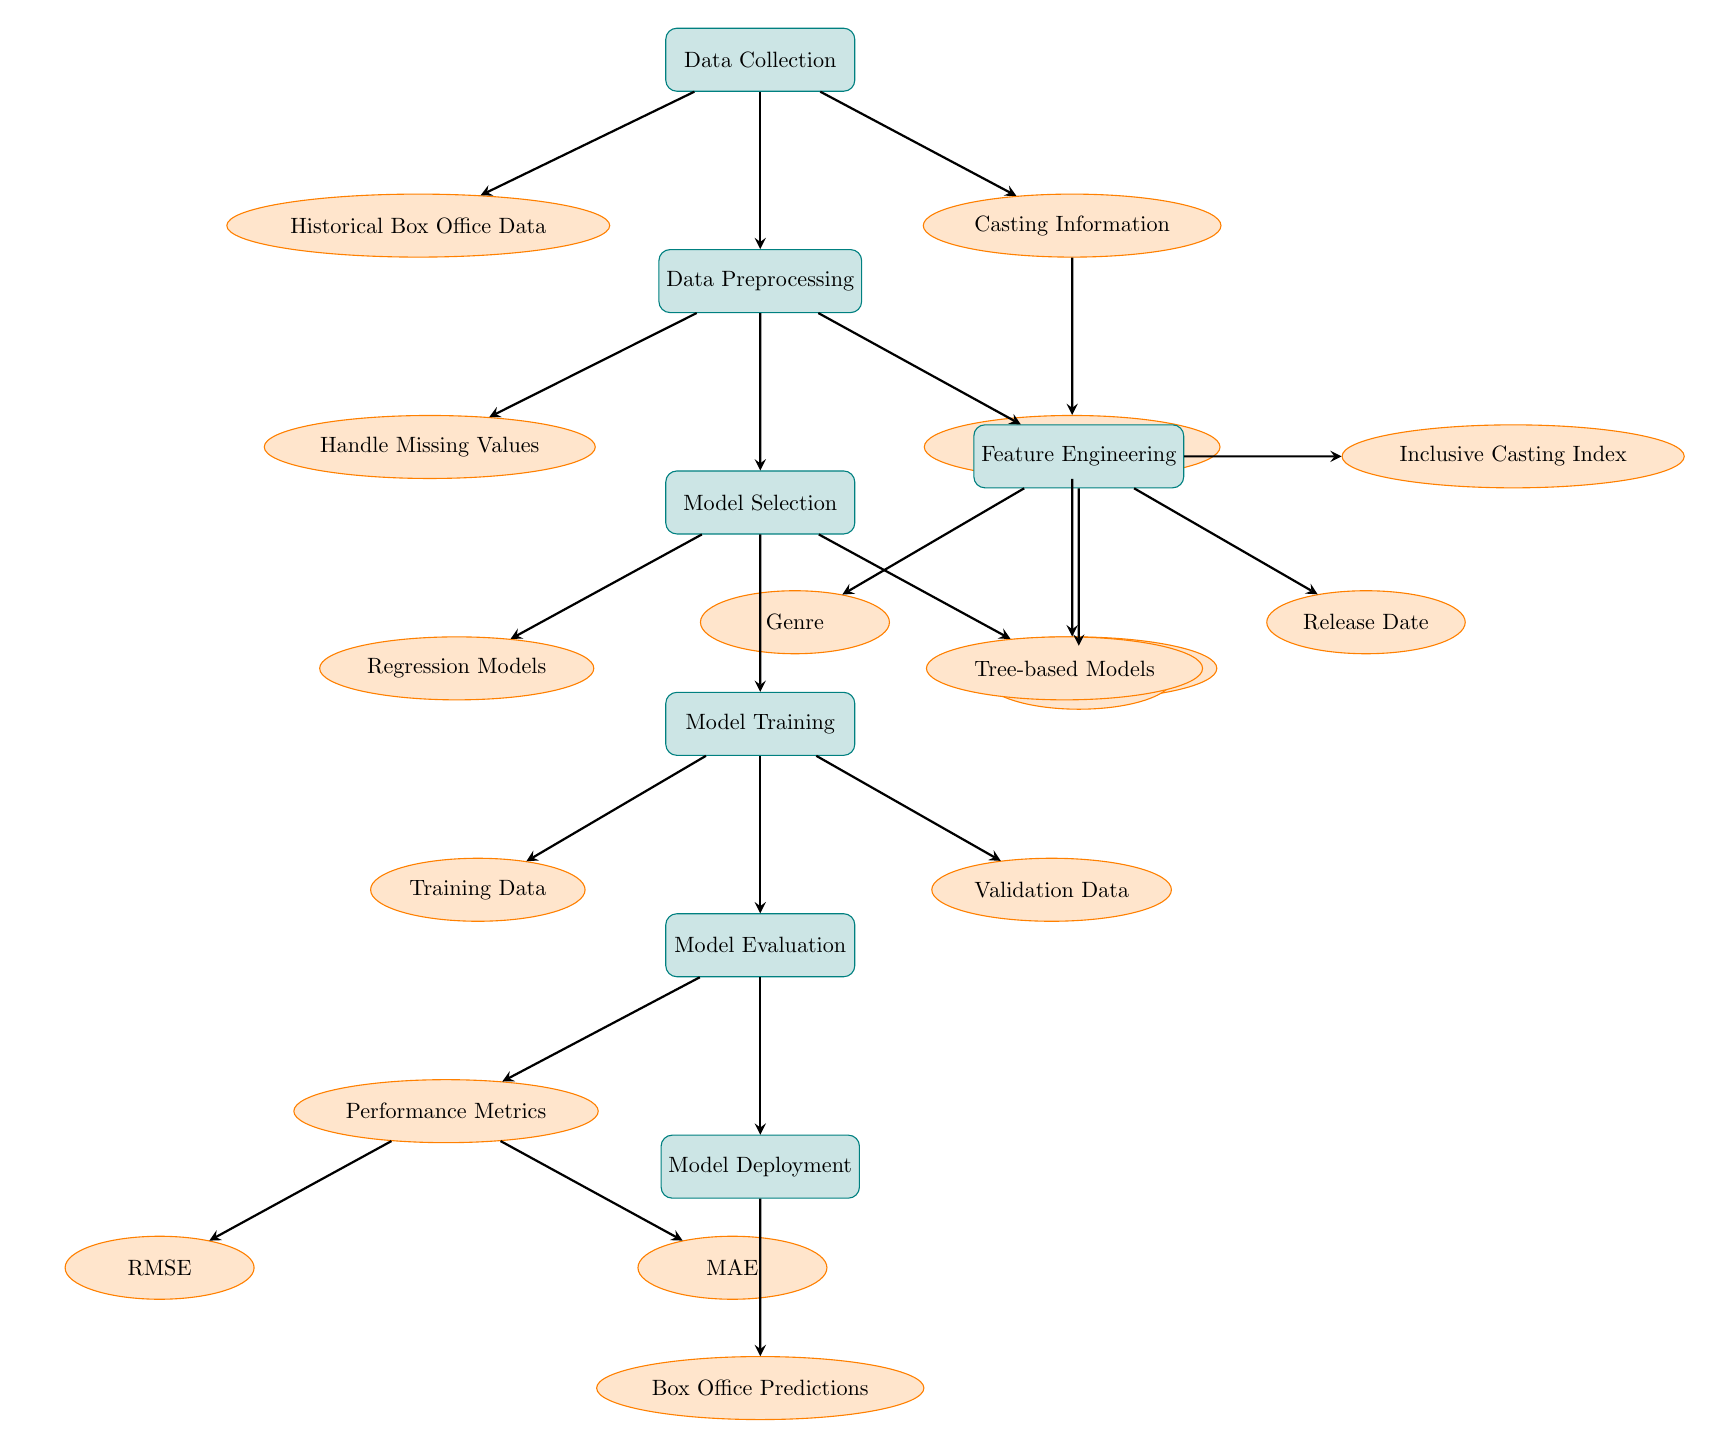What is the first step in the process? The diagram starts with the "Data Collection" node, indicating that this is the first step in the predictive modeling process.
Answer: Data Collection How many types of models are selected in the Model Selection phase? In the "Model Selection" node, there are two specified types: "Regression Models" and "Tree-based Models." Therefore, there are two types of models selected.
Answer: Two What node comes after "Data Preprocessing"? Following the "Data Preprocessing" node in the diagram is the "Model Selection" node, indicating the next phase in the workflow.
Answer: Model Selection Which node is directly connected to "Casting Information"? The "Diversity in Casting" node is directly connected to "Casting Information," showing the flow of data and how casting influences diversity.
Answer: Diversity in Casting What performance metrics are evaluated after Model Evaluation? The performance metrics evaluated are "RMSE" and "MAE," as these are listed directly under the "Performance Metrics" node in the diagram.
Answer: RMSE and MAE What type of information is included in the "Training Data"? "Training Data" is a process that receives input from "Model Training," and it typically contains the features and historical data used to train the model.
Answer: Features and historical data What is the output of the diagram after the final step? The final output generated from the "Model Deployment" node is "Box Office Predictions," which is the result of the entire modeling process.
Answer: Box Office Predictions Which node represents the handling of missing data? The "Handle Missing Values" node is specifically designated in the diagram as the step responsible for addressing any missing data during preprocessing.
Answer: Handle Missing Values What is the role of the "Inclusive Casting Index"? The "Inclusive Casting Index" is an important feature created during the "Feature Engineering" phase, reflecting the level of inclusivity in casting for the films.
Answer: Feature reflecting inclusivity 